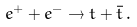<formula> <loc_0><loc_0><loc_500><loc_500>e ^ { + } + e ^ { - } \rightarrow t + \bar { t } \, .</formula> 